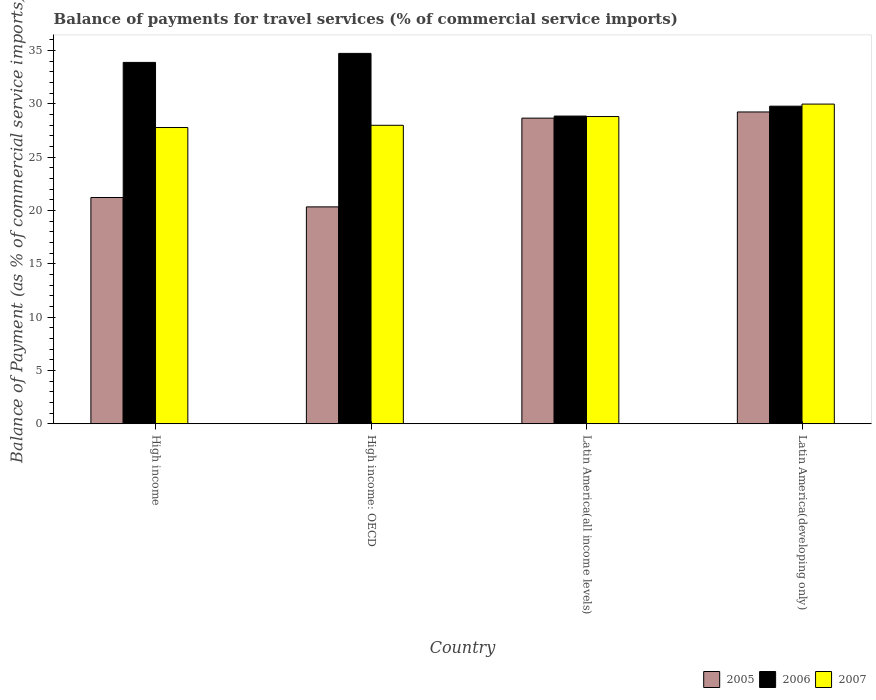Are the number of bars per tick equal to the number of legend labels?
Your answer should be very brief. Yes. How many bars are there on the 1st tick from the right?
Ensure brevity in your answer.  3. What is the label of the 4th group of bars from the left?
Your answer should be very brief. Latin America(developing only). In how many cases, is the number of bars for a given country not equal to the number of legend labels?
Keep it short and to the point. 0. What is the balance of payments for travel services in 2005 in High income: OECD?
Your answer should be very brief. 20.33. Across all countries, what is the maximum balance of payments for travel services in 2006?
Give a very brief answer. 34.72. Across all countries, what is the minimum balance of payments for travel services in 2007?
Your response must be concise. 27.77. In which country was the balance of payments for travel services in 2005 maximum?
Provide a short and direct response. Latin America(developing only). In which country was the balance of payments for travel services in 2005 minimum?
Provide a succinct answer. High income: OECD. What is the total balance of payments for travel services in 2006 in the graph?
Your answer should be very brief. 127.21. What is the difference between the balance of payments for travel services in 2006 in High income and that in High income: OECD?
Ensure brevity in your answer.  -0.84. What is the difference between the balance of payments for travel services in 2005 in High income and the balance of payments for travel services in 2007 in Latin America(all income levels)?
Your response must be concise. -7.59. What is the average balance of payments for travel services in 2007 per country?
Make the answer very short. 28.63. What is the difference between the balance of payments for travel services of/in 2007 and balance of payments for travel services of/in 2005 in Latin America(all income levels)?
Make the answer very short. 0.15. What is the ratio of the balance of payments for travel services in 2005 in High income to that in High income: OECD?
Offer a terse response. 1.04. Is the difference between the balance of payments for travel services in 2007 in High income and Latin America(developing only) greater than the difference between the balance of payments for travel services in 2005 in High income and Latin America(developing only)?
Ensure brevity in your answer.  Yes. What is the difference between the highest and the second highest balance of payments for travel services in 2007?
Offer a terse response. -0.82. What is the difference between the highest and the lowest balance of payments for travel services in 2006?
Make the answer very short. 5.88. In how many countries, is the balance of payments for travel services in 2006 greater than the average balance of payments for travel services in 2006 taken over all countries?
Keep it short and to the point. 2. What does the 2nd bar from the left in Latin America(developing only) represents?
Offer a very short reply. 2006. What does the 2nd bar from the right in Latin America(developing only) represents?
Your answer should be very brief. 2006. Is it the case that in every country, the sum of the balance of payments for travel services in 2005 and balance of payments for travel services in 2006 is greater than the balance of payments for travel services in 2007?
Make the answer very short. Yes. How many bars are there?
Offer a very short reply. 12. Does the graph contain any zero values?
Your answer should be compact. No. Where does the legend appear in the graph?
Give a very brief answer. Bottom right. How many legend labels are there?
Your answer should be very brief. 3. What is the title of the graph?
Provide a short and direct response. Balance of payments for travel services (% of commercial service imports). What is the label or title of the Y-axis?
Give a very brief answer. Balance of Payment (as % of commercial service imports). What is the Balance of Payment (as % of commercial service imports) in 2005 in High income?
Make the answer very short. 21.21. What is the Balance of Payment (as % of commercial service imports) in 2006 in High income?
Make the answer very short. 33.88. What is the Balance of Payment (as % of commercial service imports) in 2007 in High income?
Make the answer very short. 27.77. What is the Balance of Payment (as % of commercial service imports) of 2005 in High income: OECD?
Your answer should be compact. 20.33. What is the Balance of Payment (as % of commercial service imports) of 2006 in High income: OECD?
Your answer should be very brief. 34.72. What is the Balance of Payment (as % of commercial service imports) in 2007 in High income: OECD?
Your answer should be compact. 27.98. What is the Balance of Payment (as % of commercial service imports) of 2005 in Latin America(all income levels)?
Keep it short and to the point. 28.65. What is the Balance of Payment (as % of commercial service imports) of 2006 in Latin America(all income levels)?
Offer a terse response. 28.84. What is the Balance of Payment (as % of commercial service imports) in 2007 in Latin America(all income levels)?
Your answer should be very brief. 28.8. What is the Balance of Payment (as % of commercial service imports) in 2005 in Latin America(developing only)?
Give a very brief answer. 29.23. What is the Balance of Payment (as % of commercial service imports) in 2006 in Latin America(developing only)?
Make the answer very short. 29.77. What is the Balance of Payment (as % of commercial service imports) in 2007 in Latin America(developing only)?
Give a very brief answer. 29.97. Across all countries, what is the maximum Balance of Payment (as % of commercial service imports) in 2005?
Provide a succinct answer. 29.23. Across all countries, what is the maximum Balance of Payment (as % of commercial service imports) in 2006?
Ensure brevity in your answer.  34.72. Across all countries, what is the maximum Balance of Payment (as % of commercial service imports) of 2007?
Provide a succinct answer. 29.97. Across all countries, what is the minimum Balance of Payment (as % of commercial service imports) in 2005?
Your answer should be very brief. 20.33. Across all countries, what is the minimum Balance of Payment (as % of commercial service imports) of 2006?
Your response must be concise. 28.84. Across all countries, what is the minimum Balance of Payment (as % of commercial service imports) in 2007?
Ensure brevity in your answer.  27.77. What is the total Balance of Payment (as % of commercial service imports) in 2005 in the graph?
Provide a short and direct response. 99.42. What is the total Balance of Payment (as % of commercial service imports) in 2006 in the graph?
Your answer should be compact. 127.21. What is the total Balance of Payment (as % of commercial service imports) of 2007 in the graph?
Offer a terse response. 114.52. What is the difference between the Balance of Payment (as % of commercial service imports) of 2005 in High income and that in High income: OECD?
Offer a terse response. 0.88. What is the difference between the Balance of Payment (as % of commercial service imports) of 2006 in High income and that in High income: OECD?
Provide a succinct answer. -0.84. What is the difference between the Balance of Payment (as % of commercial service imports) in 2007 in High income and that in High income: OECD?
Provide a succinct answer. -0.21. What is the difference between the Balance of Payment (as % of commercial service imports) in 2005 in High income and that in Latin America(all income levels)?
Keep it short and to the point. -7.44. What is the difference between the Balance of Payment (as % of commercial service imports) in 2006 in High income and that in Latin America(all income levels)?
Your response must be concise. 5.03. What is the difference between the Balance of Payment (as % of commercial service imports) in 2007 in High income and that in Latin America(all income levels)?
Your response must be concise. -1.03. What is the difference between the Balance of Payment (as % of commercial service imports) in 2005 in High income and that in Latin America(developing only)?
Keep it short and to the point. -8.02. What is the difference between the Balance of Payment (as % of commercial service imports) of 2006 in High income and that in Latin America(developing only)?
Offer a very short reply. 4.1. What is the difference between the Balance of Payment (as % of commercial service imports) in 2007 in High income and that in Latin America(developing only)?
Your response must be concise. -2.2. What is the difference between the Balance of Payment (as % of commercial service imports) in 2005 in High income: OECD and that in Latin America(all income levels)?
Provide a succinct answer. -8.32. What is the difference between the Balance of Payment (as % of commercial service imports) in 2006 in High income: OECD and that in Latin America(all income levels)?
Provide a short and direct response. 5.88. What is the difference between the Balance of Payment (as % of commercial service imports) of 2007 in High income: OECD and that in Latin America(all income levels)?
Offer a terse response. -0.82. What is the difference between the Balance of Payment (as % of commercial service imports) in 2005 in High income: OECD and that in Latin America(developing only)?
Make the answer very short. -8.9. What is the difference between the Balance of Payment (as % of commercial service imports) of 2006 in High income: OECD and that in Latin America(developing only)?
Offer a terse response. 4.95. What is the difference between the Balance of Payment (as % of commercial service imports) of 2007 in High income: OECD and that in Latin America(developing only)?
Ensure brevity in your answer.  -1.99. What is the difference between the Balance of Payment (as % of commercial service imports) of 2005 in Latin America(all income levels) and that in Latin America(developing only)?
Give a very brief answer. -0.58. What is the difference between the Balance of Payment (as % of commercial service imports) of 2006 in Latin America(all income levels) and that in Latin America(developing only)?
Offer a very short reply. -0.93. What is the difference between the Balance of Payment (as % of commercial service imports) of 2007 in Latin America(all income levels) and that in Latin America(developing only)?
Ensure brevity in your answer.  -1.17. What is the difference between the Balance of Payment (as % of commercial service imports) in 2005 in High income and the Balance of Payment (as % of commercial service imports) in 2006 in High income: OECD?
Provide a short and direct response. -13.51. What is the difference between the Balance of Payment (as % of commercial service imports) in 2005 in High income and the Balance of Payment (as % of commercial service imports) in 2007 in High income: OECD?
Your answer should be compact. -6.77. What is the difference between the Balance of Payment (as % of commercial service imports) in 2006 in High income and the Balance of Payment (as % of commercial service imports) in 2007 in High income: OECD?
Provide a short and direct response. 5.9. What is the difference between the Balance of Payment (as % of commercial service imports) of 2005 in High income and the Balance of Payment (as % of commercial service imports) of 2006 in Latin America(all income levels)?
Your answer should be very brief. -7.63. What is the difference between the Balance of Payment (as % of commercial service imports) in 2005 in High income and the Balance of Payment (as % of commercial service imports) in 2007 in Latin America(all income levels)?
Your response must be concise. -7.59. What is the difference between the Balance of Payment (as % of commercial service imports) of 2006 in High income and the Balance of Payment (as % of commercial service imports) of 2007 in Latin America(all income levels)?
Your answer should be compact. 5.08. What is the difference between the Balance of Payment (as % of commercial service imports) in 2005 in High income and the Balance of Payment (as % of commercial service imports) in 2006 in Latin America(developing only)?
Give a very brief answer. -8.56. What is the difference between the Balance of Payment (as % of commercial service imports) in 2005 in High income and the Balance of Payment (as % of commercial service imports) in 2007 in Latin America(developing only)?
Offer a very short reply. -8.76. What is the difference between the Balance of Payment (as % of commercial service imports) in 2006 in High income and the Balance of Payment (as % of commercial service imports) in 2007 in Latin America(developing only)?
Provide a short and direct response. 3.91. What is the difference between the Balance of Payment (as % of commercial service imports) of 2005 in High income: OECD and the Balance of Payment (as % of commercial service imports) of 2006 in Latin America(all income levels)?
Provide a succinct answer. -8.51. What is the difference between the Balance of Payment (as % of commercial service imports) of 2005 in High income: OECD and the Balance of Payment (as % of commercial service imports) of 2007 in Latin America(all income levels)?
Your answer should be very brief. -8.47. What is the difference between the Balance of Payment (as % of commercial service imports) in 2006 in High income: OECD and the Balance of Payment (as % of commercial service imports) in 2007 in Latin America(all income levels)?
Provide a short and direct response. 5.92. What is the difference between the Balance of Payment (as % of commercial service imports) of 2005 in High income: OECD and the Balance of Payment (as % of commercial service imports) of 2006 in Latin America(developing only)?
Offer a very short reply. -9.44. What is the difference between the Balance of Payment (as % of commercial service imports) of 2005 in High income: OECD and the Balance of Payment (as % of commercial service imports) of 2007 in Latin America(developing only)?
Your response must be concise. -9.64. What is the difference between the Balance of Payment (as % of commercial service imports) of 2006 in High income: OECD and the Balance of Payment (as % of commercial service imports) of 2007 in Latin America(developing only)?
Ensure brevity in your answer.  4.75. What is the difference between the Balance of Payment (as % of commercial service imports) in 2005 in Latin America(all income levels) and the Balance of Payment (as % of commercial service imports) in 2006 in Latin America(developing only)?
Make the answer very short. -1.12. What is the difference between the Balance of Payment (as % of commercial service imports) of 2005 in Latin America(all income levels) and the Balance of Payment (as % of commercial service imports) of 2007 in Latin America(developing only)?
Provide a short and direct response. -1.32. What is the difference between the Balance of Payment (as % of commercial service imports) in 2006 in Latin America(all income levels) and the Balance of Payment (as % of commercial service imports) in 2007 in Latin America(developing only)?
Your response must be concise. -1.12. What is the average Balance of Payment (as % of commercial service imports) in 2005 per country?
Give a very brief answer. 24.86. What is the average Balance of Payment (as % of commercial service imports) in 2006 per country?
Give a very brief answer. 31.8. What is the average Balance of Payment (as % of commercial service imports) of 2007 per country?
Your answer should be very brief. 28.63. What is the difference between the Balance of Payment (as % of commercial service imports) in 2005 and Balance of Payment (as % of commercial service imports) in 2006 in High income?
Provide a succinct answer. -12.67. What is the difference between the Balance of Payment (as % of commercial service imports) of 2005 and Balance of Payment (as % of commercial service imports) of 2007 in High income?
Give a very brief answer. -6.56. What is the difference between the Balance of Payment (as % of commercial service imports) in 2006 and Balance of Payment (as % of commercial service imports) in 2007 in High income?
Provide a short and direct response. 6.11. What is the difference between the Balance of Payment (as % of commercial service imports) in 2005 and Balance of Payment (as % of commercial service imports) in 2006 in High income: OECD?
Provide a succinct answer. -14.39. What is the difference between the Balance of Payment (as % of commercial service imports) in 2005 and Balance of Payment (as % of commercial service imports) in 2007 in High income: OECD?
Your response must be concise. -7.65. What is the difference between the Balance of Payment (as % of commercial service imports) in 2006 and Balance of Payment (as % of commercial service imports) in 2007 in High income: OECD?
Your response must be concise. 6.74. What is the difference between the Balance of Payment (as % of commercial service imports) of 2005 and Balance of Payment (as % of commercial service imports) of 2006 in Latin America(all income levels)?
Provide a short and direct response. -0.19. What is the difference between the Balance of Payment (as % of commercial service imports) of 2005 and Balance of Payment (as % of commercial service imports) of 2007 in Latin America(all income levels)?
Ensure brevity in your answer.  -0.15. What is the difference between the Balance of Payment (as % of commercial service imports) of 2006 and Balance of Payment (as % of commercial service imports) of 2007 in Latin America(all income levels)?
Ensure brevity in your answer.  0.04. What is the difference between the Balance of Payment (as % of commercial service imports) in 2005 and Balance of Payment (as % of commercial service imports) in 2006 in Latin America(developing only)?
Provide a succinct answer. -0.54. What is the difference between the Balance of Payment (as % of commercial service imports) of 2005 and Balance of Payment (as % of commercial service imports) of 2007 in Latin America(developing only)?
Offer a very short reply. -0.74. What is the difference between the Balance of Payment (as % of commercial service imports) in 2006 and Balance of Payment (as % of commercial service imports) in 2007 in Latin America(developing only)?
Provide a succinct answer. -0.2. What is the ratio of the Balance of Payment (as % of commercial service imports) of 2005 in High income to that in High income: OECD?
Your answer should be very brief. 1.04. What is the ratio of the Balance of Payment (as % of commercial service imports) in 2006 in High income to that in High income: OECD?
Your response must be concise. 0.98. What is the ratio of the Balance of Payment (as % of commercial service imports) in 2007 in High income to that in High income: OECD?
Your response must be concise. 0.99. What is the ratio of the Balance of Payment (as % of commercial service imports) in 2005 in High income to that in Latin America(all income levels)?
Provide a succinct answer. 0.74. What is the ratio of the Balance of Payment (as % of commercial service imports) of 2006 in High income to that in Latin America(all income levels)?
Provide a succinct answer. 1.17. What is the ratio of the Balance of Payment (as % of commercial service imports) of 2007 in High income to that in Latin America(all income levels)?
Your answer should be compact. 0.96. What is the ratio of the Balance of Payment (as % of commercial service imports) of 2005 in High income to that in Latin America(developing only)?
Make the answer very short. 0.73. What is the ratio of the Balance of Payment (as % of commercial service imports) of 2006 in High income to that in Latin America(developing only)?
Keep it short and to the point. 1.14. What is the ratio of the Balance of Payment (as % of commercial service imports) in 2007 in High income to that in Latin America(developing only)?
Your answer should be compact. 0.93. What is the ratio of the Balance of Payment (as % of commercial service imports) of 2005 in High income: OECD to that in Latin America(all income levels)?
Keep it short and to the point. 0.71. What is the ratio of the Balance of Payment (as % of commercial service imports) of 2006 in High income: OECD to that in Latin America(all income levels)?
Your answer should be very brief. 1.2. What is the ratio of the Balance of Payment (as % of commercial service imports) of 2007 in High income: OECD to that in Latin America(all income levels)?
Make the answer very short. 0.97. What is the ratio of the Balance of Payment (as % of commercial service imports) of 2005 in High income: OECD to that in Latin America(developing only)?
Make the answer very short. 0.7. What is the ratio of the Balance of Payment (as % of commercial service imports) in 2006 in High income: OECD to that in Latin America(developing only)?
Ensure brevity in your answer.  1.17. What is the ratio of the Balance of Payment (as % of commercial service imports) of 2007 in High income: OECD to that in Latin America(developing only)?
Ensure brevity in your answer.  0.93. What is the ratio of the Balance of Payment (as % of commercial service imports) in 2005 in Latin America(all income levels) to that in Latin America(developing only)?
Provide a succinct answer. 0.98. What is the ratio of the Balance of Payment (as % of commercial service imports) in 2006 in Latin America(all income levels) to that in Latin America(developing only)?
Offer a terse response. 0.97. What is the ratio of the Balance of Payment (as % of commercial service imports) of 2007 in Latin America(all income levels) to that in Latin America(developing only)?
Provide a short and direct response. 0.96. What is the difference between the highest and the second highest Balance of Payment (as % of commercial service imports) of 2005?
Your response must be concise. 0.58. What is the difference between the highest and the second highest Balance of Payment (as % of commercial service imports) in 2006?
Make the answer very short. 0.84. What is the difference between the highest and the second highest Balance of Payment (as % of commercial service imports) of 2007?
Your answer should be compact. 1.17. What is the difference between the highest and the lowest Balance of Payment (as % of commercial service imports) of 2005?
Ensure brevity in your answer.  8.9. What is the difference between the highest and the lowest Balance of Payment (as % of commercial service imports) in 2006?
Give a very brief answer. 5.88. What is the difference between the highest and the lowest Balance of Payment (as % of commercial service imports) of 2007?
Your response must be concise. 2.2. 